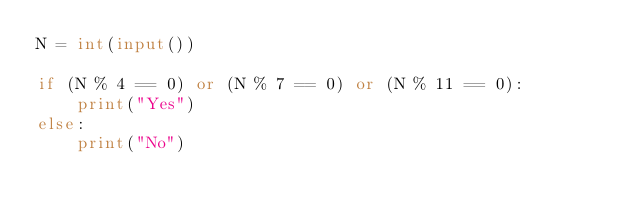<code> <loc_0><loc_0><loc_500><loc_500><_Python_>N = int(input())

if (N % 4 == 0) or (N % 7 == 0) or (N % 11 == 0):
    print("Yes")
else:
    print("No")</code> 